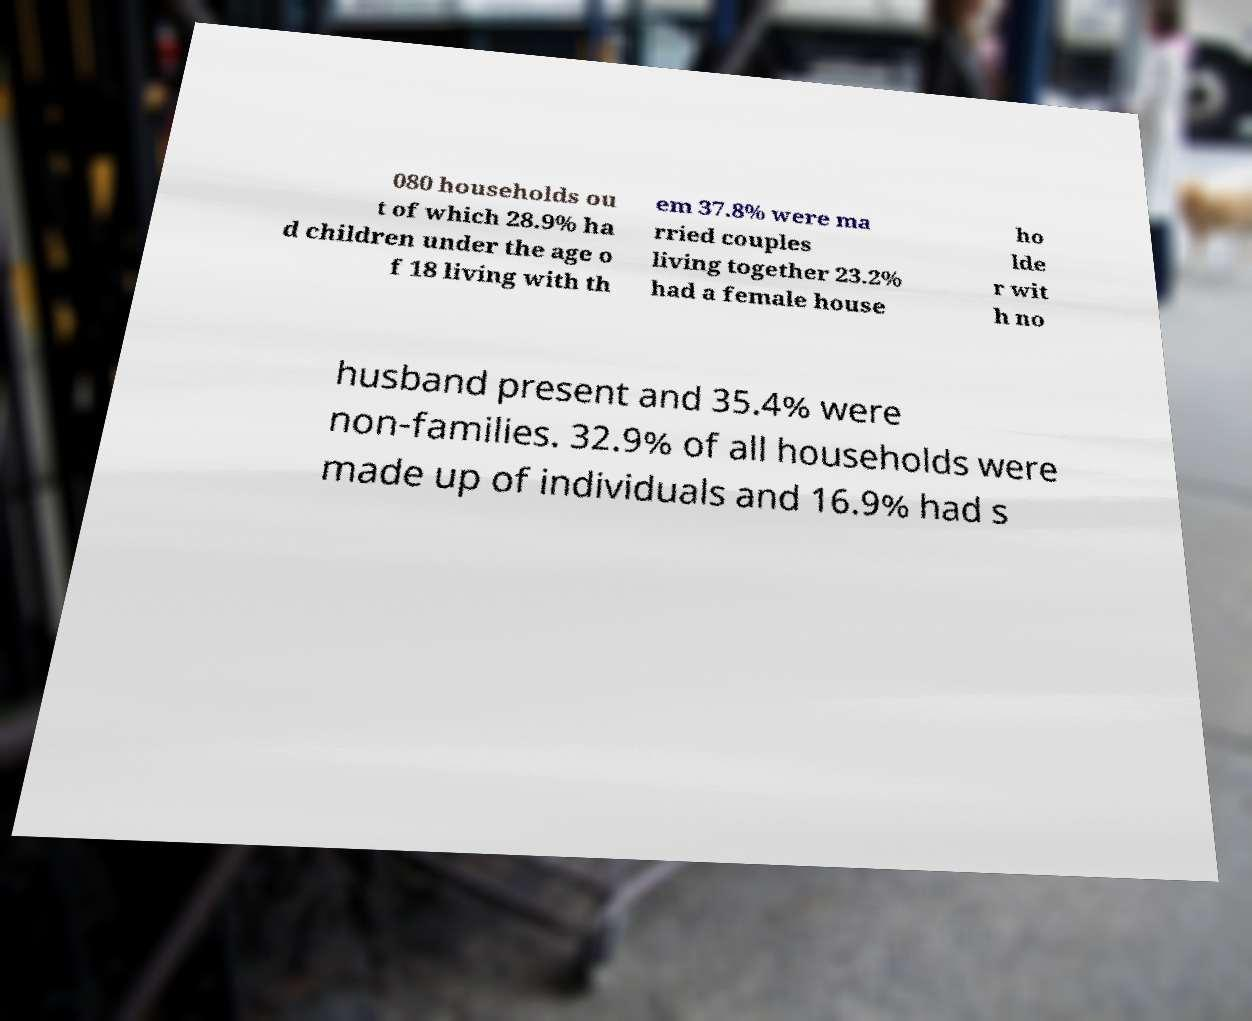For documentation purposes, I need the text within this image transcribed. Could you provide that? 080 households ou t of which 28.9% ha d children under the age o f 18 living with th em 37.8% were ma rried couples living together 23.2% had a female house ho lde r wit h no husband present and 35.4% were non-families. 32.9% of all households were made up of individuals and 16.9% had s 